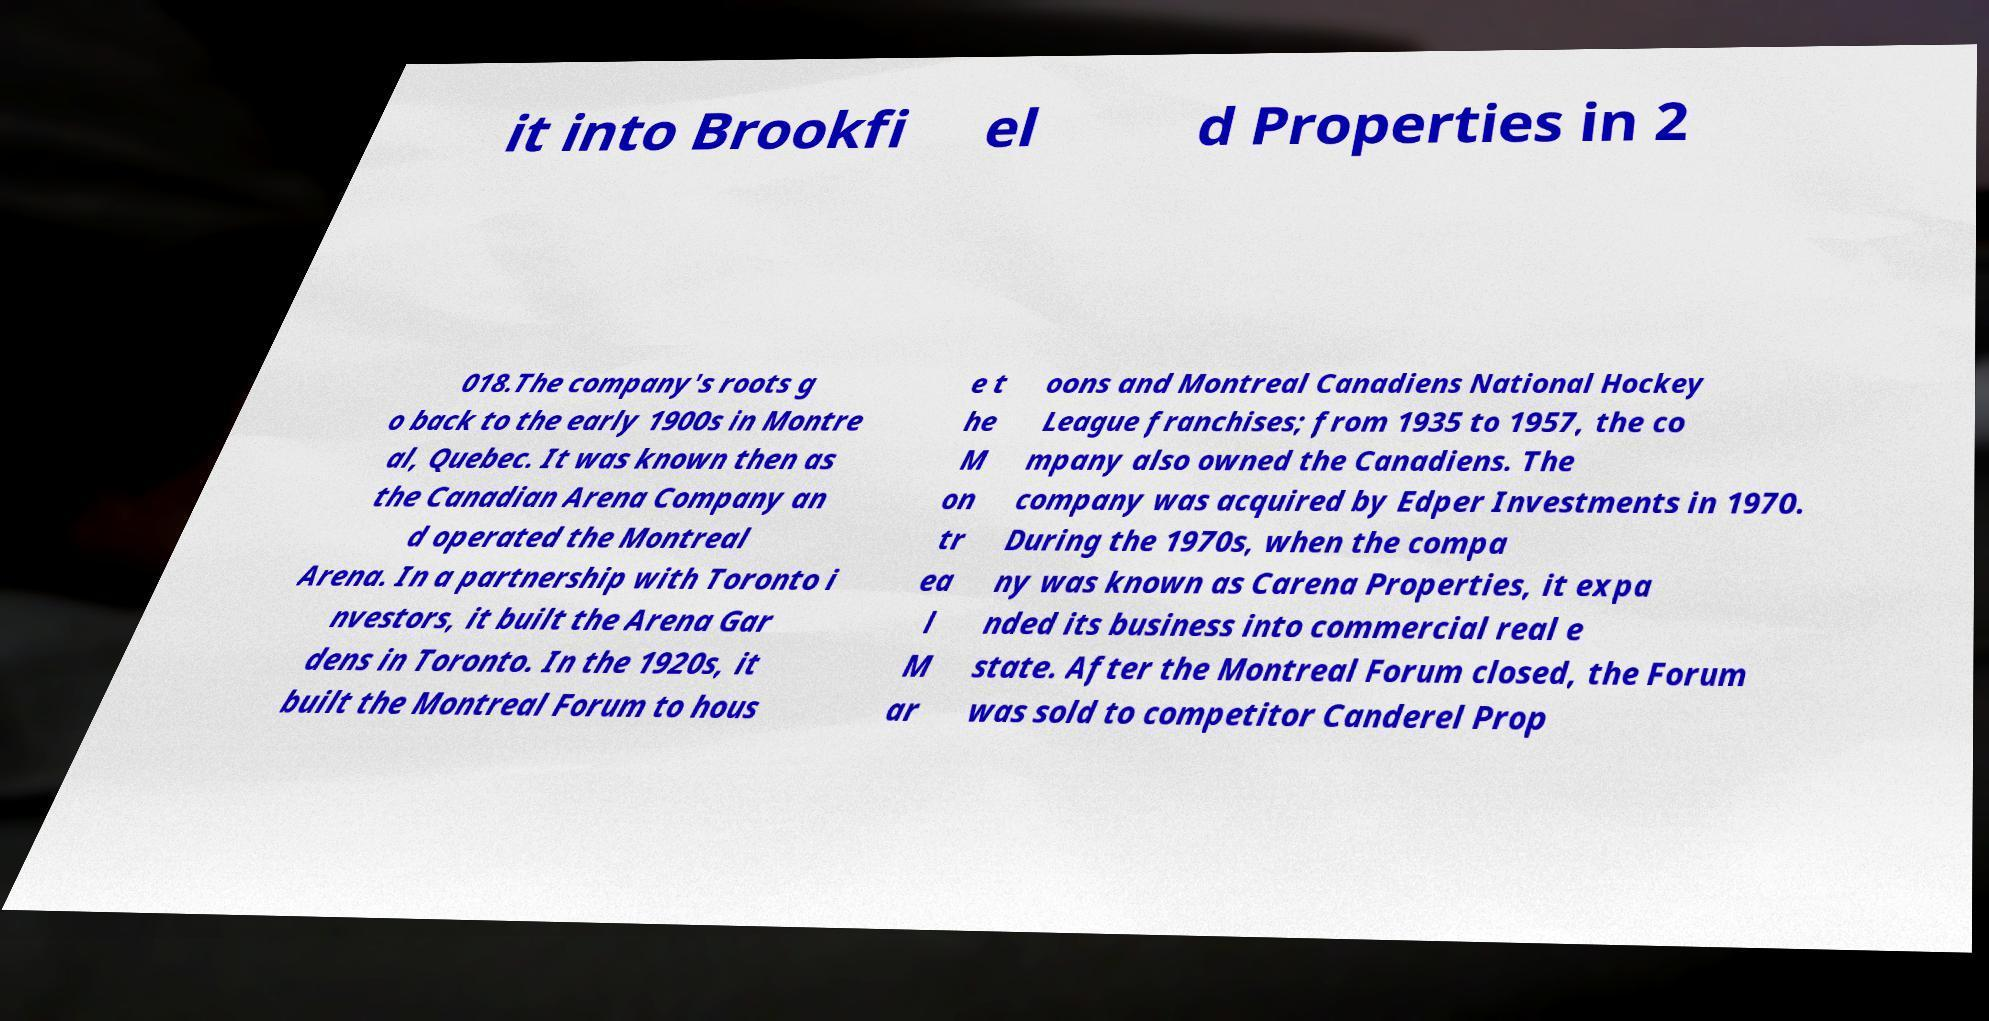Please identify and transcribe the text found in this image. it into Brookfi el d Properties in 2 018.The company's roots g o back to the early 1900s in Montre al, Quebec. It was known then as the Canadian Arena Company an d operated the Montreal Arena. In a partnership with Toronto i nvestors, it built the Arena Gar dens in Toronto. In the 1920s, it built the Montreal Forum to hous e t he M on tr ea l M ar oons and Montreal Canadiens National Hockey League franchises; from 1935 to 1957, the co mpany also owned the Canadiens. The company was acquired by Edper Investments in 1970. During the 1970s, when the compa ny was known as Carena Properties, it expa nded its business into commercial real e state. After the Montreal Forum closed, the Forum was sold to competitor Canderel Prop 